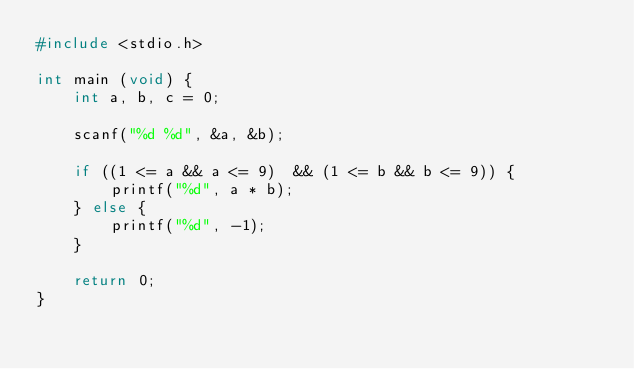Convert code to text. <code><loc_0><loc_0><loc_500><loc_500><_C_>#include <stdio.h>

int main (void) {
    int a, b, c = 0;

    scanf("%d %d", &a, &b);

    if ((1 <= a && a <= 9)  && (1 <= b && b <= 9)) {
        printf("%d", a * b);
    } else {
        printf("%d", -1);
    }

    return 0;
}</code> 